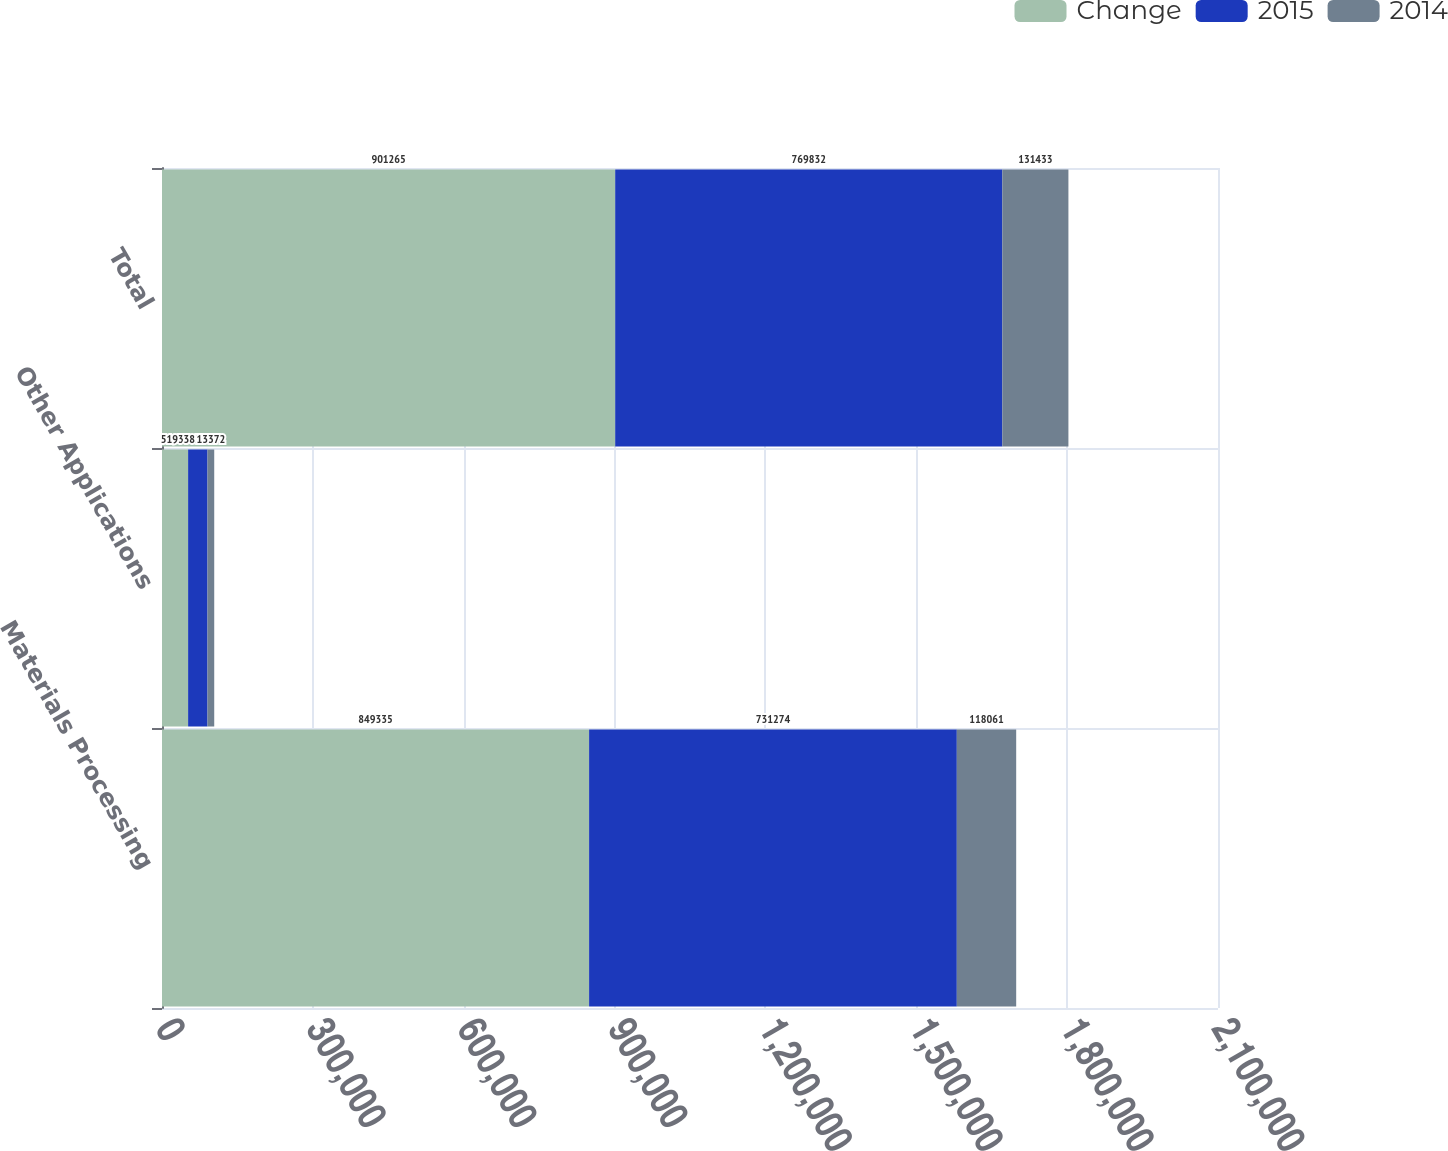Convert chart to OTSL. <chart><loc_0><loc_0><loc_500><loc_500><stacked_bar_chart><ecel><fcel>Materials Processing<fcel>Other Applications<fcel>Total<nl><fcel>Change<fcel>849335<fcel>51930<fcel>901265<nl><fcel>2015<fcel>731274<fcel>38558<fcel>769832<nl><fcel>2014<fcel>118061<fcel>13372<fcel>131433<nl></chart> 